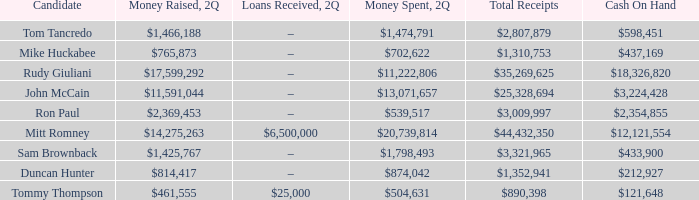Tell me the total receipts for tom tancredo $2,807,879. 